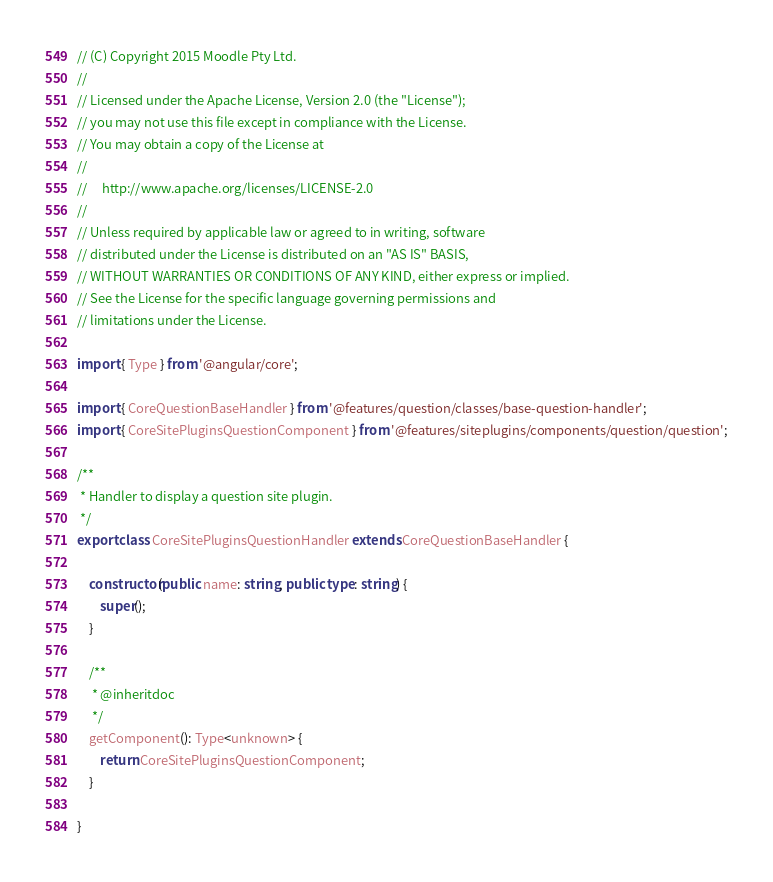<code> <loc_0><loc_0><loc_500><loc_500><_TypeScript_>// (C) Copyright 2015 Moodle Pty Ltd.
//
// Licensed under the Apache License, Version 2.0 (the "License");
// you may not use this file except in compliance with the License.
// You may obtain a copy of the License at
//
//     http://www.apache.org/licenses/LICENSE-2.0
//
// Unless required by applicable law or agreed to in writing, software
// distributed under the License is distributed on an "AS IS" BASIS,
// WITHOUT WARRANTIES OR CONDITIONS OF ANY KIND, either express or implied.
// See the License for the specific language governing permissions and
// limitations under the License.

import { Type } from '@angular/core';

import { CoreQuestionBaseHandler } from '@features/question/classes/base-question-handler';
import { CoreSitePluginsQuestionComponent } from '@features/siteplugins/components/question/question';

/**
 * Handler to display a question site plugin.
 */
export class CoreSitePluginsQuestionHandler extends CoreQuestionBaseHandler {

    constructor(public name: string, public type: string) {
        super();
    }

    /**
     * @inheritdoc
     */
    getComponent(): Type<unknown> {
        return CoreSitePluginsQuestionComponent;
    }

}
</code> 